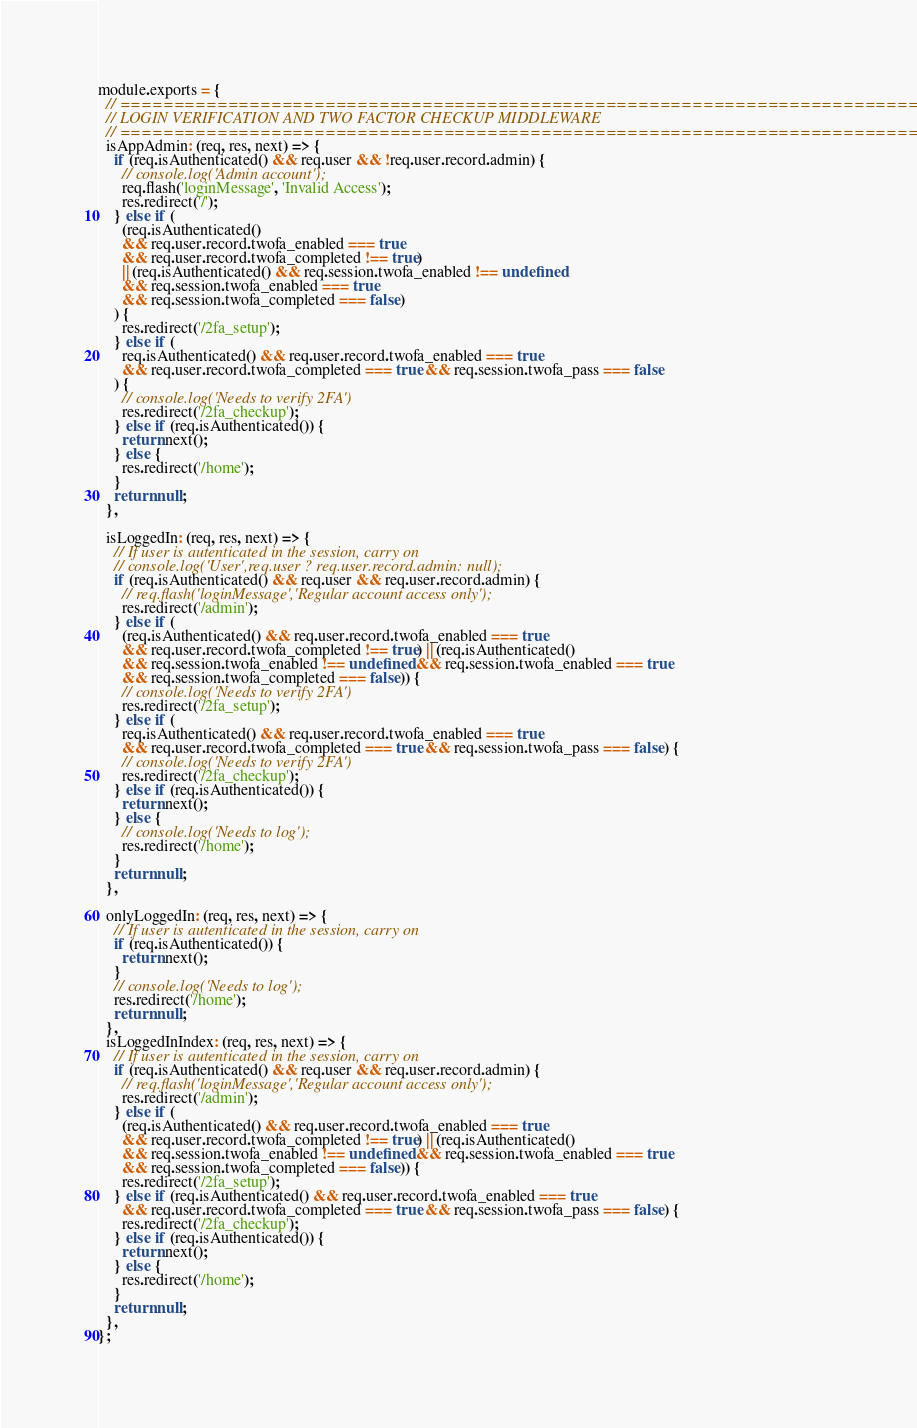<code> <loc_0><loc_0><loc_500><loc_500><_JavaScript_>module.exports = {
  // ===============================================================================
  // LOGIN VERIFICATION AND TWO FACTOR CHECKUP MIDDLEWARE
  // ===============================================================================
  isAppAdmin: (req, res, next) => {
    if (req.isAuthenticated() && req.user && !req.user.record.admin) {
      // console.log('Admin account');
      req.flash('loginMessage', 'Invalid Access');
      res.redirect('/');
    } else if (
      (req.isAuthenticated()
      && req.user.record.twofa_enabled === true
      && req.user.record.twofa_completed !== true)
      || (req.isAuthenticated() && req.session.twofa_enabled !== undefined
      && req.session.twofa_enabled === true
      && req.session.twofa_completed === false)
    ) {
      res.redirect('/2fa_setup');
    } else if (
      req.isAuthenticated() && req.user.record.twofa_enabled === true
      && req.user.record.twofa_completed === true && req.session.twofa_pass === false
    ) {
      // console.log('Needs to verify 2FA')
      res.redirect('/2fa_checkup');
    } else if (req.isAuthenticated()) {
      return next();
    } else {
      res.redirect('/home');
    }
    return null;
  },

  isLoggedIn: (req, res, next) => {
    // If user is autenticated in the session, carry on
    // console.log('User',req.user ? req.user.record.admin: null);
    if (req.isAuthenticated() && req.user && req.user.record.admin) {
      // req.flash('loginMessage','Regular account access only');
      res.redirect('/admin');
    } else if (
      (req.isAuthenticated() && req.user.record.twofa_enabled === true
      && req.user.record.twofa_completed !== true) || (req.isAuthenticated()
      && req.session.twofa_enabled !== undefined && req.session.twofa_enabled === true
      && req.session.twofa_completed === false)) {
      // console.log('Needs to verify 2FA')
      res.redirect('/2fa_setup');
    } else if (
      req.isAuthenticated() && req.user.record.twofa_enabled === true
      && req.user.record.twofa_completed === true && req.session.twofa_pass === false) {
      // console.log('Needs to verify 2FA')
      res.redirect('/2fa_checkup');
    } else if (req.isAuthenticated()) {
      return next();
    } else {
      // console.log('Needs to log');
      res.redirect('/home');
    }
    return null;
  },

  onlyLoggedIn: (req, res, next) => {
    // If user is autenticated in the session, carry on
    if (req.isAuthenticated()) {
      return next();
    }
    // console.log('Needs to log');
    res.redirect('/home');
    return null;
  },
  isLoggedInIndex: (req, res, next) => {
    // If user is autenticated in the session, carry on
    if (req.isAuthenticated() && req.user && req.user.record.admin) {
      // req.flash('loginMessage','Regular account access only');
      res.redirect('/admin');
    } else if (
      (req.isAuthenticated() && req.user.record.twofa_enabled === true
      && req.user.record.twofa_completed !== true) || (req.isAuthenticated()
      && req.session.twofa_enabled !== undefined && req.session.twofa_enabled === true
      && req.session.twofa_completed === false)) {
      res.redirect('/2fa_setup');
    } else if (req.isAuthenticated() && req.user.record.twofa_enabled === true
      && req.user.record.twofa_completed === true && req.session.twofa_pass === false) {
      res.redirect('/2fa_checkup');
    } else if (req.isAuthenticated()) {
      return next();
    } else {
      res.redirect('/home');
    }
    return null;
  },
};
</code> 